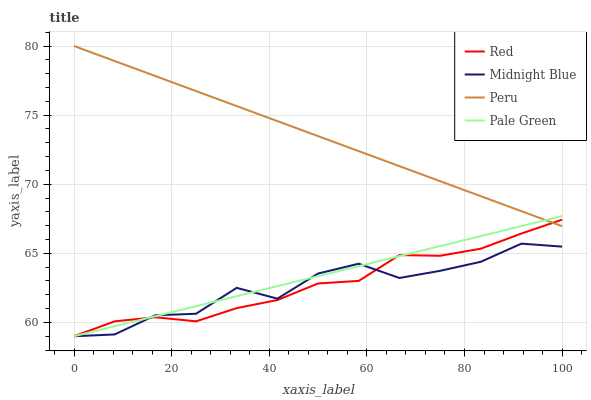Does Pale Green have the minimum area under the curve?
Answer yes or no. No. Does Pale Green have the maximum area under the curve?
Answer yes or no. No. Is Pale Green the smoothest?
Answer yes or no. No. Is Pale Green the roughest?
Answer yes or no. No. Does Pale Green have the highest value?
Answer yes or no. No. Is Midnight Blue less than Peru?
Answer yes or no. Yes. Is Peru greater than Midnight Blue?
Answer yes or no. Yes. Does Midnight Blue intersect Peru?
Answer yes or no. No. 